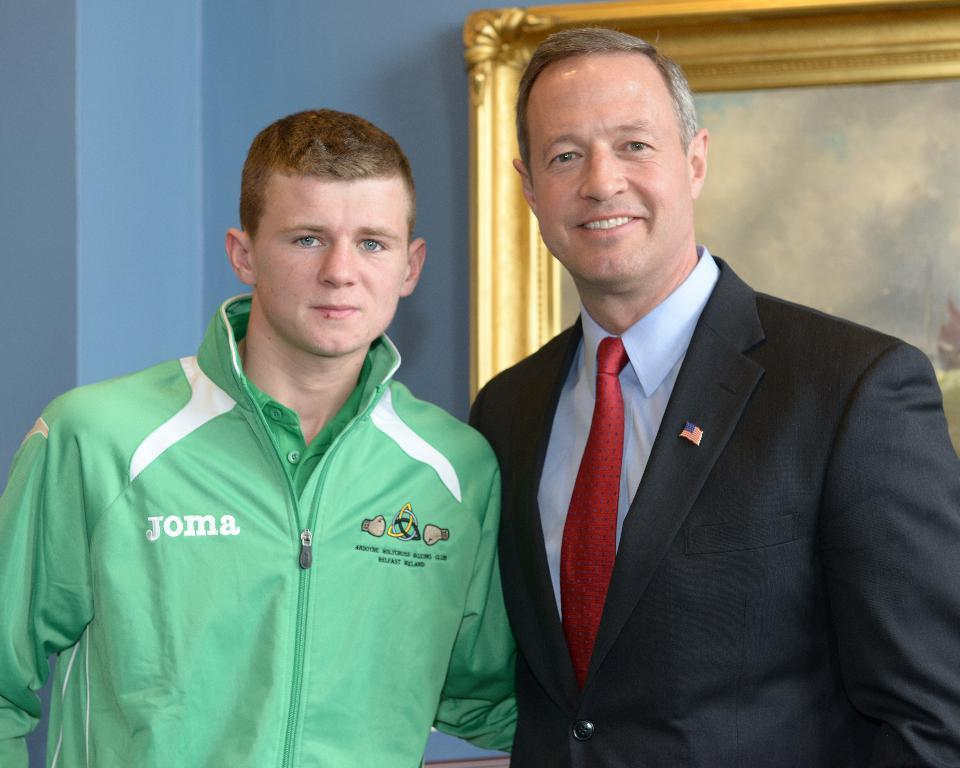<image>
Give a short and clear explanation of the subsequent image. a boy wearing a green Joma jacket next to a man 